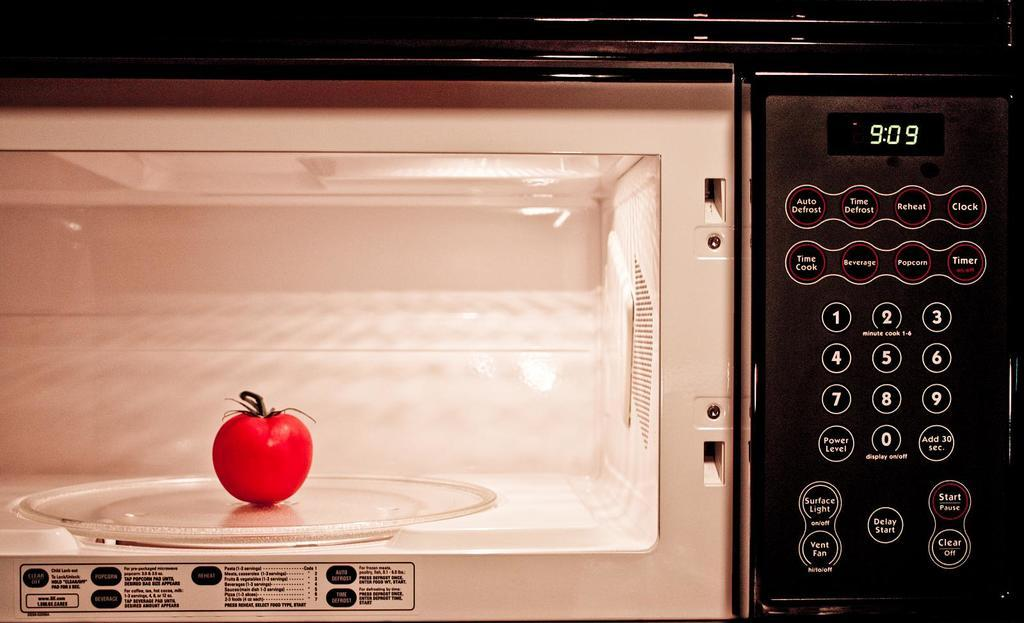<image>
Relay a brief, clear account of the picture shown. A black microwave with a timer that has "9:09" on it. 